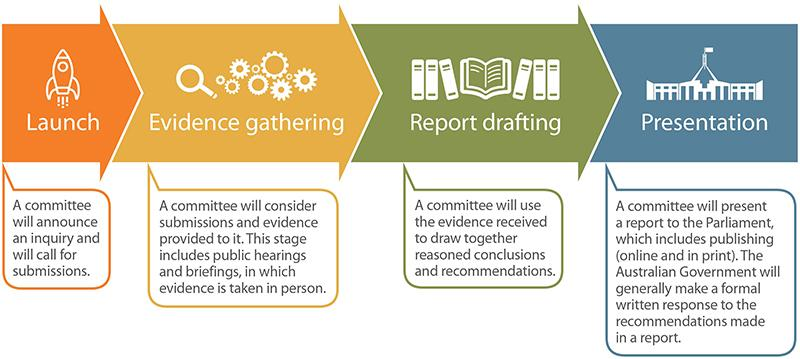Identify some key points in this picture. Evidence is taken in person through public hearings and briefings. The rocket demonstrates the act of launching into outer space. Reports are presented in both online and print formats for publishing. The final stage of any report is presentation. The files and books represent the draft of a report. 